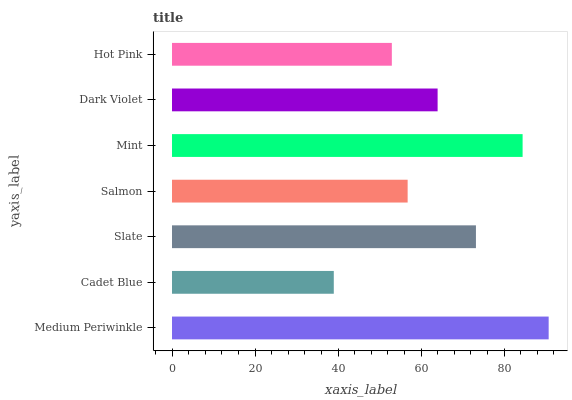Is Cadet Blue the minimum?
Answer yes or no. Yes. Is Medium Periwinkle the maximum?
Answer yes or no. Yes. Is Slate the minimum?
Answer yes or no. No. Is Slate the maximum?
Answer yes or no. No. Is Slate greater than Cadet Blue?
Answer yes or no. Yes. Is Cadet Blue less than Slate?
Answer yes or no. Yes. Is Cadet Blue greater than Slate?
Answer yes or no. No. Is Slate less than Cadet Blue?
Answer yes or no. No. Is Dark Violet the high median?
Answer yes or no. Yes. Is Dark Violet the low median?
Answer yes or no. Yes. Is Hot Pink the high median?
Answer yes or no. No. Is Salmon the low median?
Answer yes or no. No. 